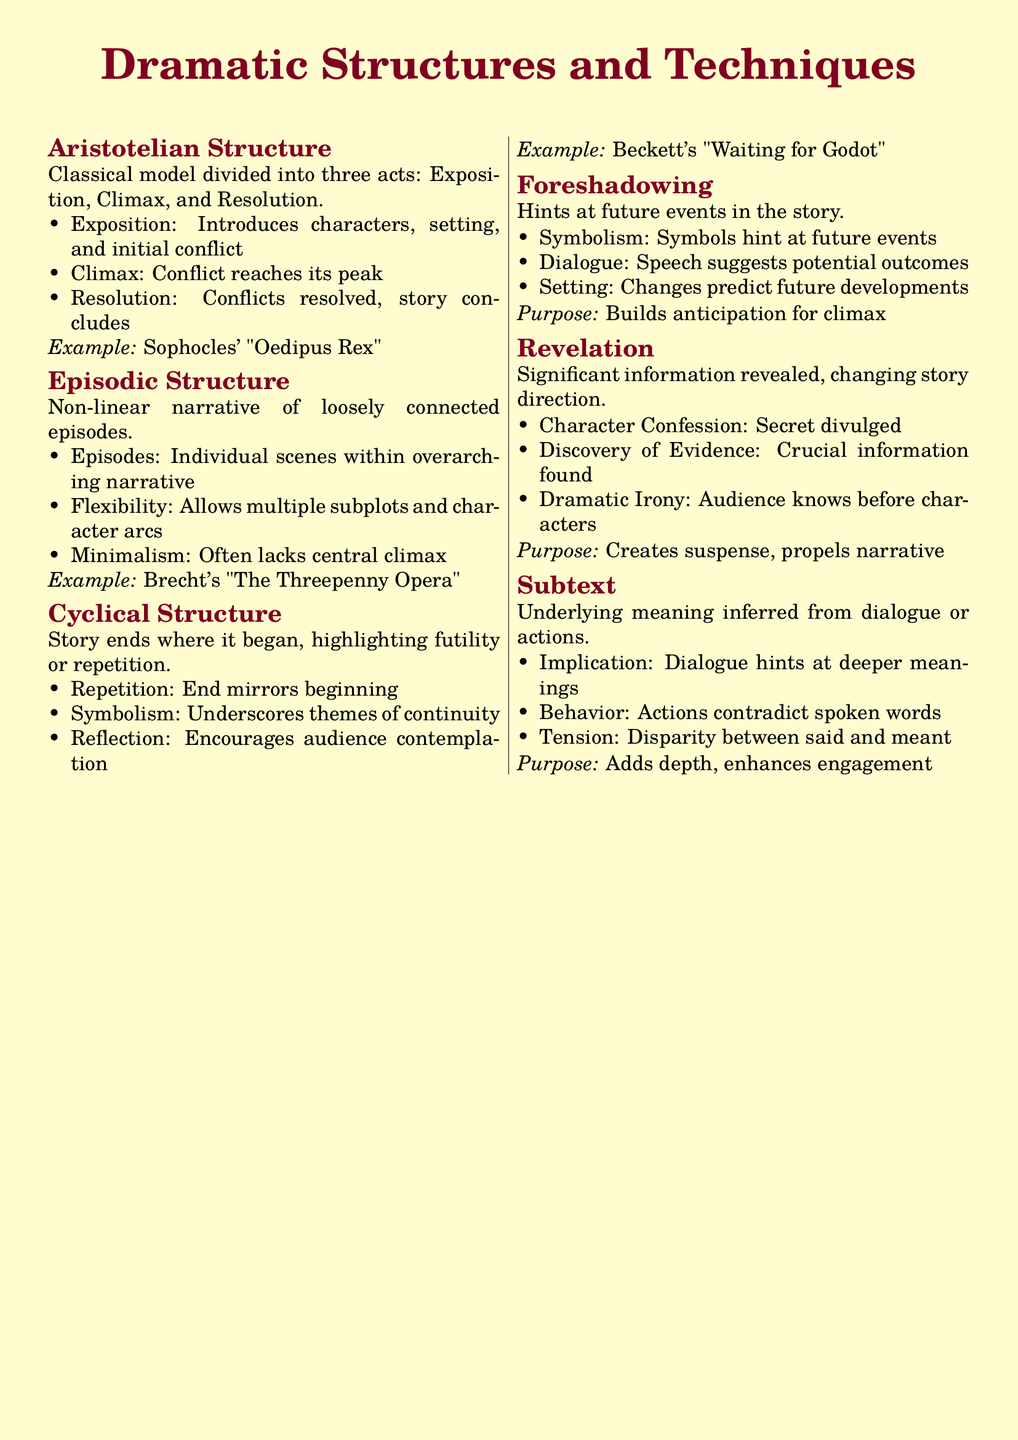What are the three acts in Aristotelian Structure? The three acts in Aristotelian Structure are Exposition, Climax, and Resolution.
Answer: Exposition, Climax, Resolution What does episodic structure allow for? Episodic structure allows for multiple subplots and character arcs.
Answer: Multiple subplots and character arcs Which playwright is associated with the Cyclical Structure? The playwright associated with the Cyclical Structure is Beckett.
Answer: Beckett What is the purpose of foreshadowing? The purpose of foreshadowing is to build anticipation for climax.
Answer: Builds anticipation for climax What is revealed during a revelation? Significant information is revealed during a revelation.
Answer: Significant information Which dramatic technique uses dialogue to convey deeper meanings? The dramatic technique that uses dialogue to convey deeper meanings is Subtext.
Answer: Subtext In which example is the climax not central? The example where the climax is not central is Brecht's "The Threepenny Opera".
Answer: Brecht's "The Threepenny Opera" What does the cyclical structure encourage? The cyclical structure encourages audience contemplation.
Answer: Audience contemplation What type of irony is highlighted in revelation? In revelation, Dramatic Irony is highlighted when the audience knows before characters.
Answer: Dramatic Irony 